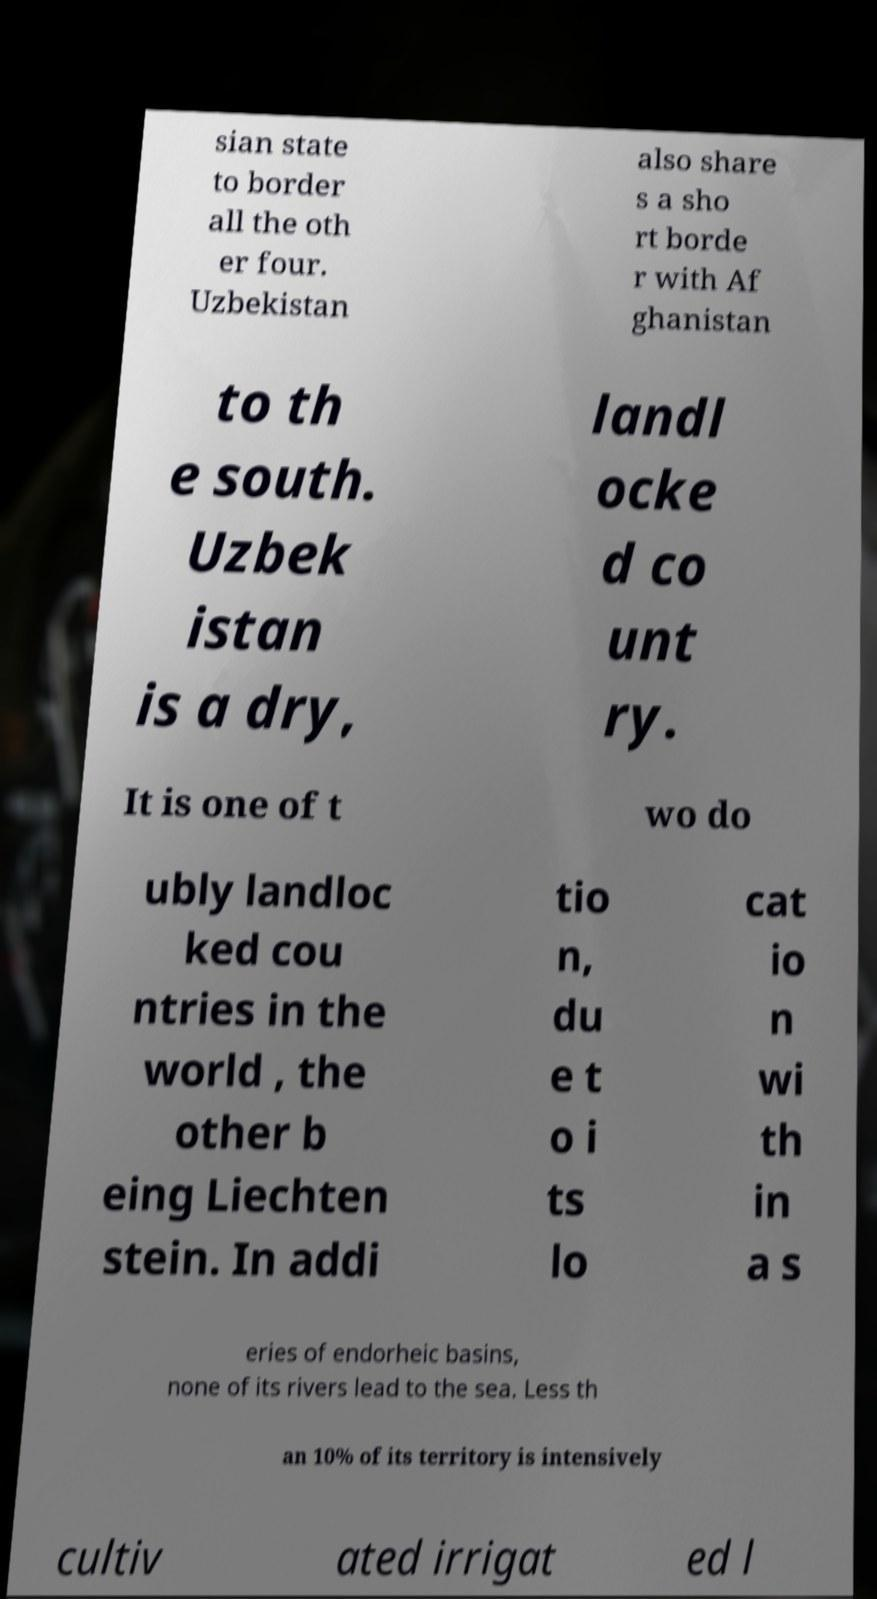I need the written content from this picture converted into text. Can you do that? sian state to border all the oth er four. Uzbekistan also share s a sho rt borde r with Af ghanistan to th e south. Uzbek istan is a dry, landl ocke d co unt ry. It is one of t wo do ubly landloc ked cou ntries in the world , the other b eing Liechten stein. In addi tio n, du e t o i ts lo cat io n wi th in a s eries of endorheic basins, none of its rivers lead to the sea. Less th an 10% of its territory is intensively cultiv ated irrigat ed l 